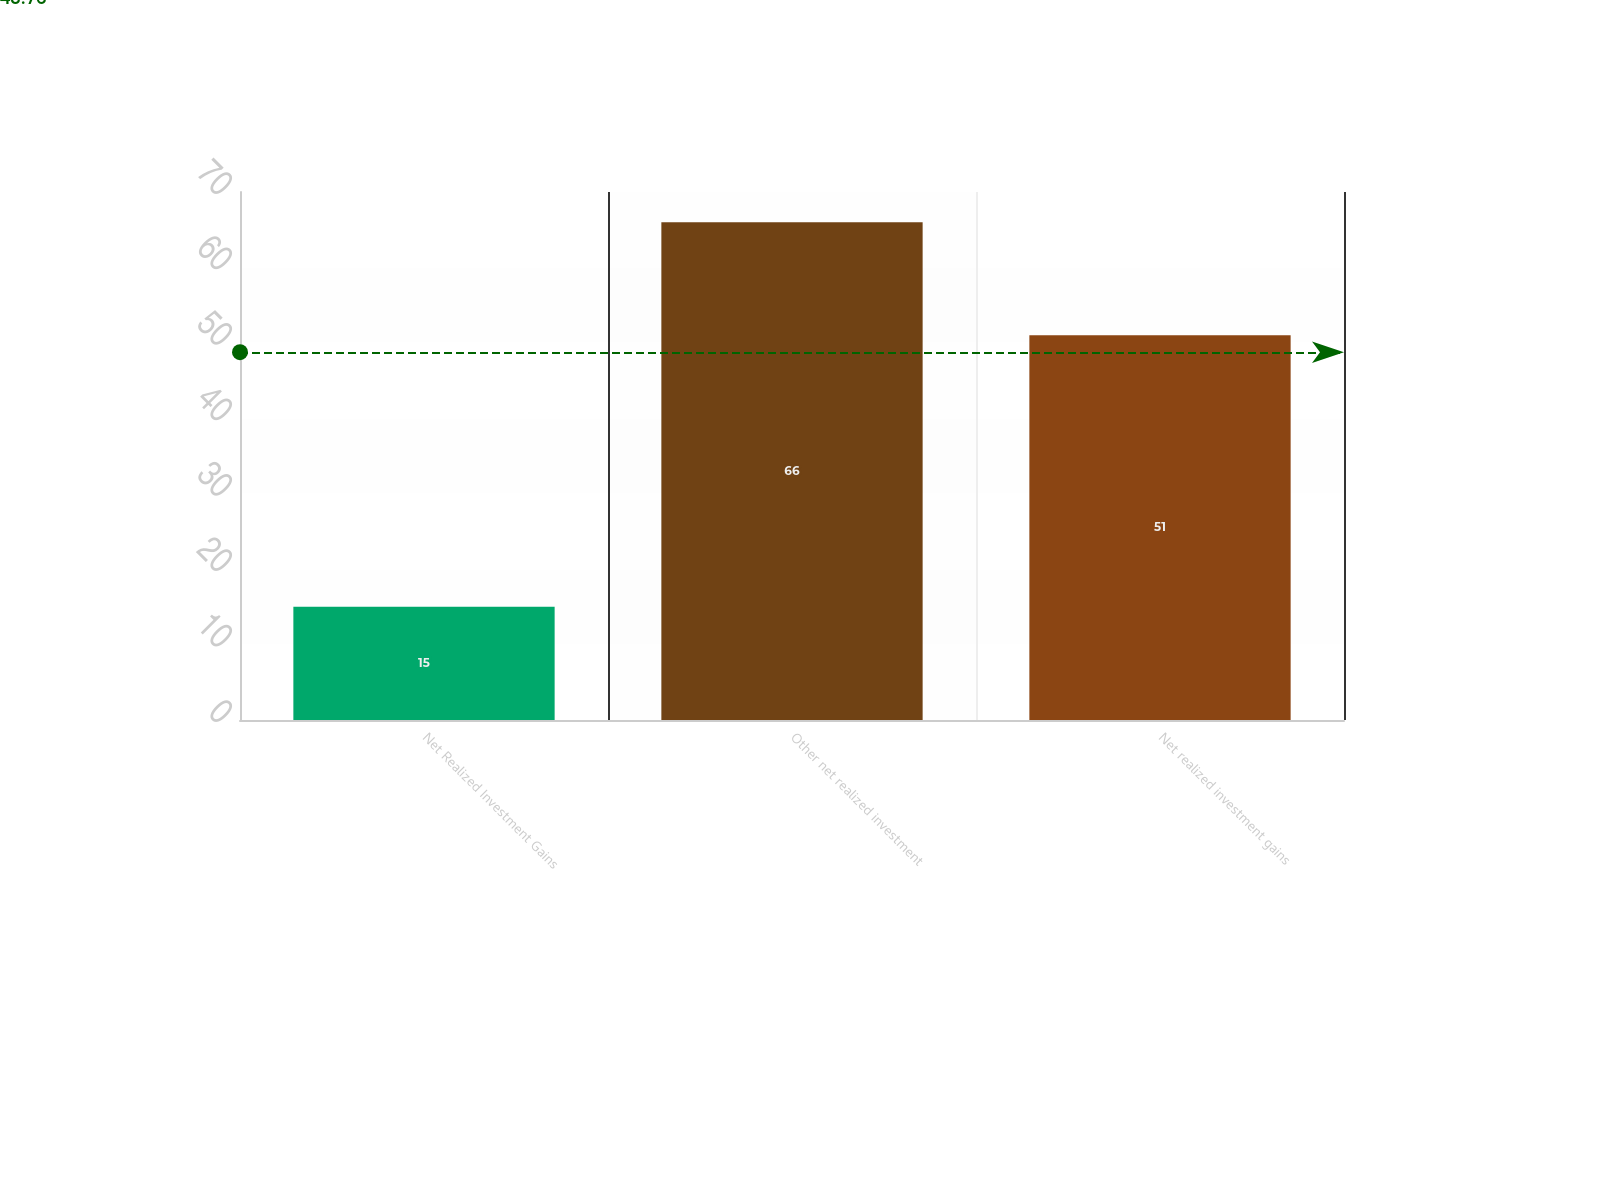<chart> <loc_0><loc_0><loc_500><loc_500><bar_chart><fcel>Net Realized Investment Gains<fcel>Other net realized investment<fcel>Net realized investment gains<nl><fcel>15<fcel>66<fcel>51<nl></chart> 